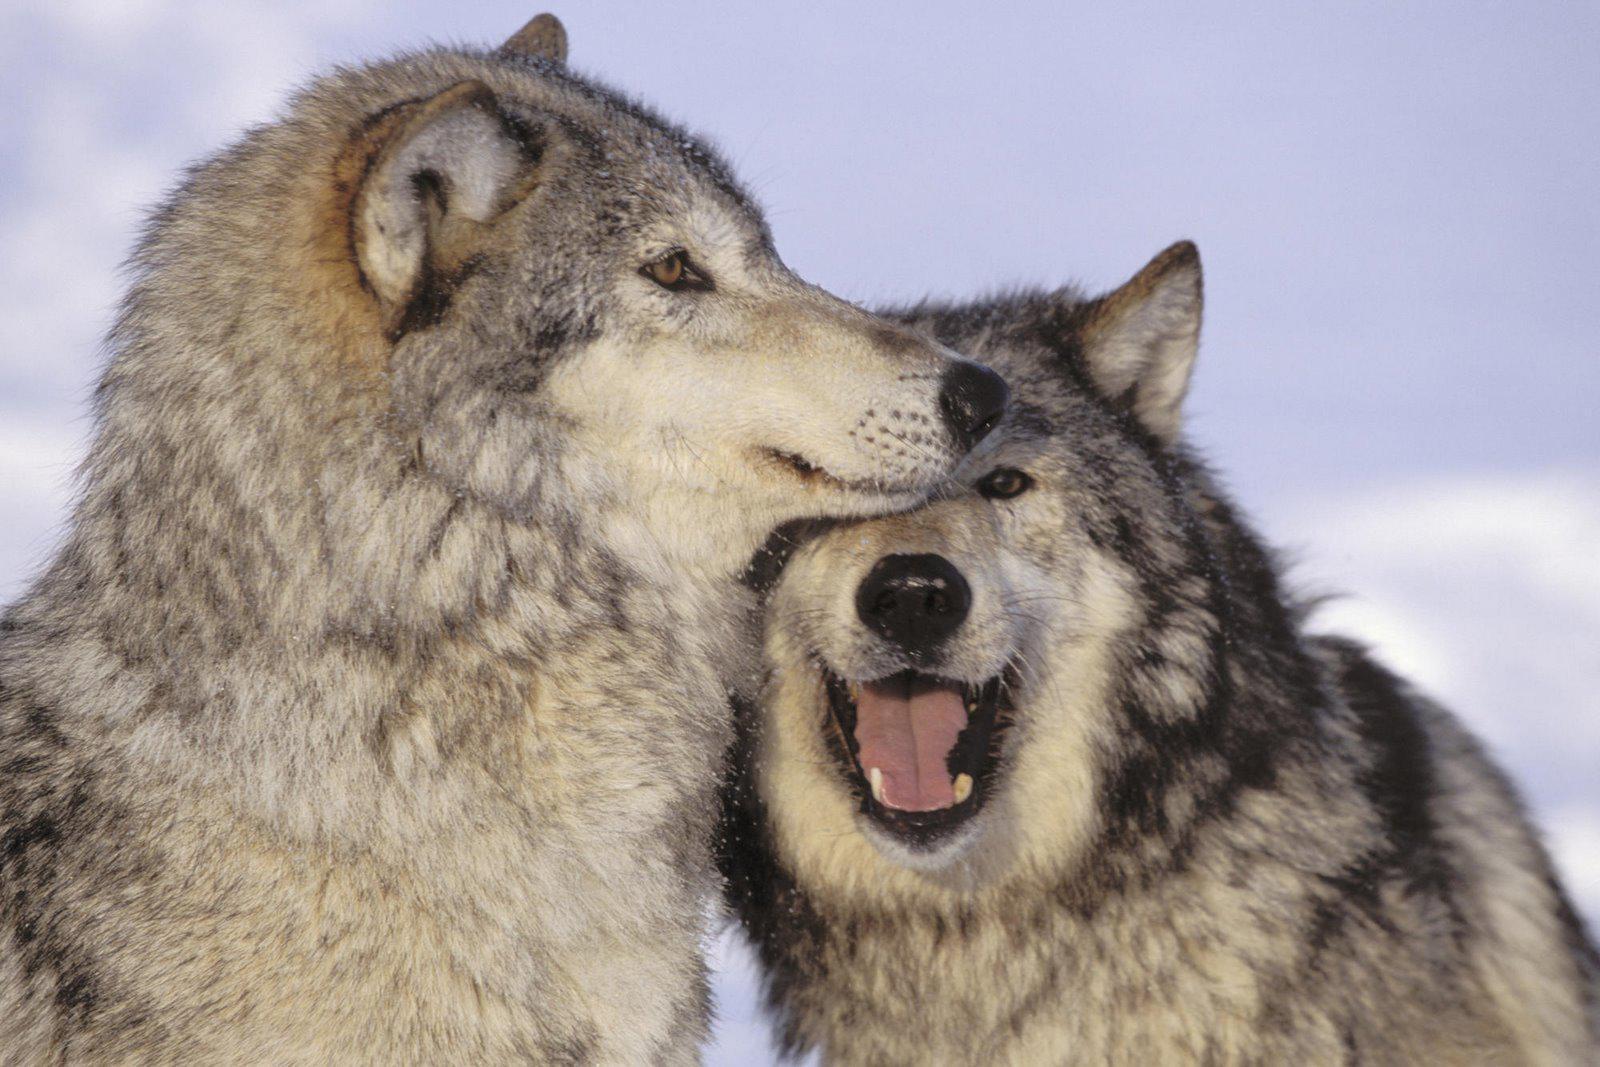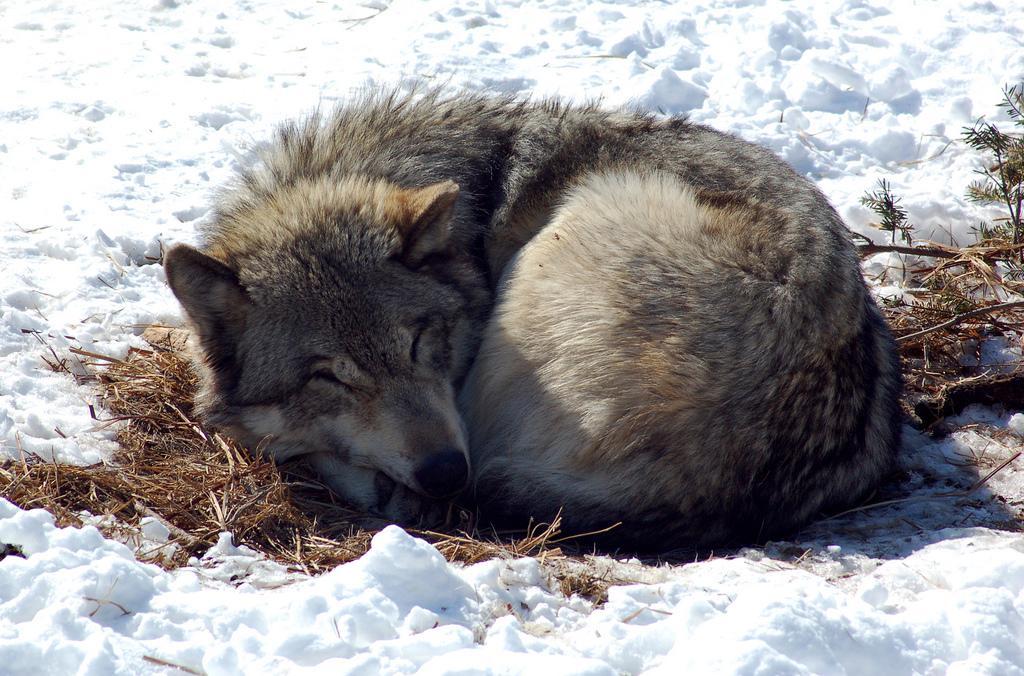The first image is the image on the left, the second image is the image on the right. Given the left and right images, does the statement "there are wolves with teeth bared in a snarl" hold true? Answer yes or no. No. 